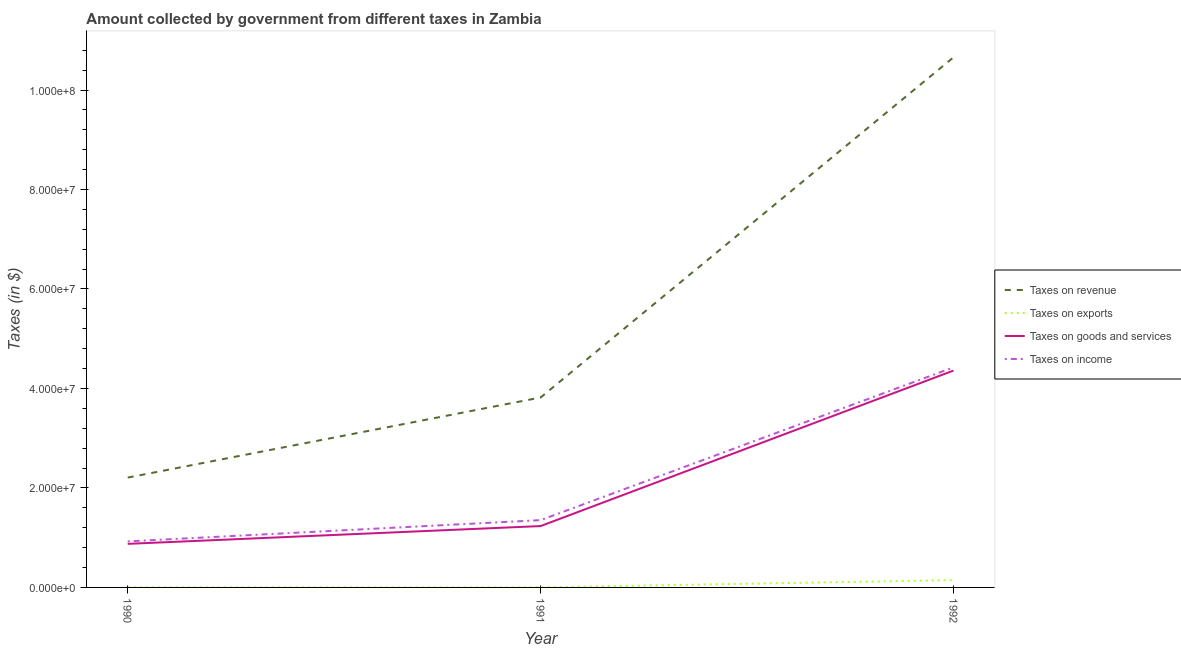How many different coloured lines are there?
Keep it short and to the point. 4. What is the amount collected as tax on revenue in 1992?
Provide a short and direct response. 1.07e+08. Across all years, what is the maximum amount collected as tax on revenue?
Your answer should be very brief. 1.07e+08. Across all years, what is the minimum amount collected as tax on revenue?
Your response must be concise. 2.21e+07. In which year was the amount collected as tax on revenue maximum?
Offer a very short reply. 1992. What is the total amount collected as tax on income in the graph?
Ensure brevity in your answer.  6.70e+07. What is the difference between the amount collected as tax on exports in 1990 and that in 1992?
Provide a succinct answer. -1.44e+06. What is the difference between the amount collected as tax on exports in 1991 and the amount collected as tax on income in 1990?
Offer a terse response. -9.24e+06. What is the average amount collected as tax on goods per year?
Offer a very short reply. 2.16e+07. In the year 1992, what is the difference between the amount collected as tax on goods and amount collected as tax on revenue?
Offer a very short reply. -6.30e+07. What is the ratio of the amount collected as tax on exports in 1991 to that in 1992?
Ensure brevity in your answer.  0.01. Is the amount collected as tax on revenue in 1990 less than that in 1992?
Provide a short and direct response. Yes. Is the difference between the amount collected as tax on exports in 1990 and 1991 greater than the difference between the amount collected as tax on revenue in 1990 and 1991?
Provide a succinct answer. Yes. What is the difference between the highest and the second highest amount collected as tax on revenue?
Provide a short and direct response. 6.84e+07. What is the difference between the highest and the lowest amount collected as tax on exports?
Ensure brevity in your answer.  1.46e+06. In how many years, is the amount collected as tax on income greater than the average amount collected as tax on income taken over all years?
Make the answer very short. 1. Is it the case that in every year, the sum of the amount collected as tax on revenue and amount collected as tax on income is greater than the sum of amount collected as tax on goods and amount collected as tax on exports?
Provide a short and direct response. No. Does the amount collected as tax on goods monotonically increase over the years?
Make the answer very short. Yes. Is the amount collected as tax on revenue strictly less than the amount collected as tax on exports over the years?
Give a very brief answer. No. How many lines are there?
Offer a very short reply. 4. How many years are there in the graph?
Make the answer very short. 3. Does the graph contain any zero values?
Keep it short and to the point. No. Where does the legend appear in the graph?
Your answer should be compact. Center right. How many legend labels are there?
Your answer should be very brief. 4. What is the title of the graph?
Your response must be concise. Amount collected by government from different taxes in Zambia. What is the label or title of the X-axis?
Offer a terse response. Year. What is the label or title of the Y-axis?
Offer a terse response. Taxes (in $). What is the Taxes (in $) of Taxes on revenue in 1990?
Provide a short and direct response. 2.21e+07. What is the Taxes (in $) in Taxes on exports in 1990?
Ensure brevity in your answer.  3.40e+04. What is the Taxes (in $) in Taxes on goods and services in 1990?
Your answer should be very brief. 8.76e+06. What is the Taxes (in $) of Taxes on income in 1990?
Make the answer very short. 9.25e+06. What is the Taxes (in $) in Taxes on revenue in 1991?
Your answer should be compact. 3.82e+07. What is the Taxes (in $) of Taxes on exports in 1991?
Your answer should be very brief. 1.19e+04. What is the Taxes (in $) of Taxes on goods and services in 1991?
Provide a succinct answer. 1.23e+07. What is the Taxes (in $) in Taxes on income in 1991?
Provide a short and direct response. 1.35e+07. What is the Taxes (in $) in Taxes on revenue in 1992?
Offer a terse response. 1.07e+08. What is the Taxes (in $) of Taxes on exports in 1992?
Your response must be concise. 1.47e+06. What is the Taxes (in $) of Taxes on goods and services in 1992?
Keep it short and to the point. 4.36e+07. What is the Taxes (in $) in Taxes on income in 1992?
Provide a succinct answer. 4.42e+07. Across all years, what is the maximum Taxes (in $) in Taxes on revenue?
Provide a succinct answer. 1.07e+08. Across all years, what is the maximum Taxes (in $) in Taxes on exports?
Offer a very short reply. 1.47e+06. Across all years, what is the maximum Taxes (in $) of Taxes on goods and services?
Keep it short and to the point. 4.36e+07. Across all years, what is the maximum Taxes (in $) in Taxes on income?
Offer a very short reply. 4.42e+07. Across all years, what is the minimum Taxes (in $) of Taxes on revenue?
Keep it short and to the point. 2.21e+07. Across all years, what is the minimum Taxes (in $) in Taxes on exports?
Make the answer very short. 1.19e+04. Across all years, what is the minimum Taxes (in $) in Taxes on goods and services?
Make the answer very short. 8.76e+06. Across all years, what is the minimum Taxes (in $) in Taxes on income?
Ensure brevity in your answer.  9.25e+06. What is the total Taxes (in $) in Taxes on revenue in the graph?
Offer a very short reply. 1.67e+08. What is the total Taxes (in $) of Taxes on exports in the graph?
Ensure brevity in your answer.  1.52e+06. What is the total Taxes (in $) of Taxes on goods and services in the graph?
Ensure brevity in your answer.  6.47e+07. What is the total Taxes (in $) of Taxes on income in the graph?
Your answer should be compact. 6.70e+07. What is the difference between the Taxes (in $) of Taxes on revenue in 1990 and that in 1991?
Your response must be concise. -1.61e+07. What is the difference between the Taxes (in $) in Taxes on exports in 1990 and that in 1991?
Provide a succinct answer. 2.21e+04. What is the difference between the Taxes (in $) in Taxes on goods and services in 1990 and that in 1991?
Offer a terse response. -3.58e+06. What is the difference between the Taxes (in $) of Taxes on income in 1990 and that in 1991?
Give a very brief answer. -4.27e+06. What is the difference between the Taxes (in $) in Taxes on revenue in 1990 and that in 1992?
Make the answer very short. -8.45e+07. What is the difference between the Taxes (in $) in Taxes on exports in 1990 and that in 1992?
Offer a terse response. -1.44e+06. What is the difference between the Taxes (in $) in Taxes on goods and services in 1990 and that in 1992?
Your response must be concise. -3.48e+07. What is the difference between the Taxes (in $) of Taxes on income in 1990 and that in 1992?
Provide a short and direct response. -3.50e+07. What is the difference between the Taxes (in $) of Taxes on revenue in 1991 and that in 1992?
Your answer should be compact. -6.84e+07. What is the difference between the Taxes (in $) in Taxes on exports in 1991 and that in 1992?
Provide a short and direct response. -1.46e+06. What is the difference between the Taxes (in $) in Taxes on goods and services in 1991 and that in 1992?
Give a very brief answer. -3.13e+07. What is the difference between the Taxes (in $) of Taxes on income in 1991 and that in 1992?
Your answer should be compact. -3.07e+07. What is the difference between the Taxes (in $) of Taxes on revenue in 1990 and the Taxes (in $) of Taxes on exports in 1991?
Provide a succinct answer. 2.21e+07. What is the difference between the Taxes (in $) in Taxes on revenue in 1990 and the Taxes (in $) in Taxes on goods and services in 1991?
Your response must be concise. 9.74e+06. What is the difference between the Taxes (in $) of Taxes on revenue in 1990 and the Taxes (in $) of Taxes on income in 1991?
Your answer should be very brief. 8.55e+06. What is the difference between the Taxes (in $) of Taxes on exports in 1990 and the Taxes (in $) of Taxes on goods and services in 1991?
Ensure brevity in your answer.  -1.23e+07. What is the difference between the Taxes (in $) in Taxes on exports in 1990 and the Taxes (in $) in Taxes on income in 1991?
Your response must be concise. -1.35e+07. What is the difference between the Taxes (in $) in Taxes on goods and services in 1990 and the Taxes (in $) in Taxes on income in 1991?
Provide a short and direct response. -4.77e+06. What is the difference between the Taxes (in $) in Taxes on revenue in 1990 and the Taxes (in $) in Taxes on exports in 1992?
Provide a succinct answer. 2.06e+07. What is the difference between the Taxes (in $) of Taxes on revenue in 1990 and the Taxes (in $) of Taxes on goods and services in 1992?
Provide a short and direct response. -2.15e+07. What is the difference between the Taxes (in $) of Taxes on revenue in 1990 and the Taxes (in $) of Taxes on income in 1992?
Provide a short and direct response. -2.22e+07. What is the difference between the Taxes (in $) in Taxes on exports in 1990 and the Taxes (in $) in Taxes on goods and services in 1992?
Give a very brief answer. -4.36e+07. What is the difference between the Taxes (in $) of Taxes on exports in 1990 and the Taxes (in $) of Taxes on income in 1992?
Ensure brevity in your answer.  -4.42e+07. What is the difference between the Taxes (in $) of Taxes on goods and services in 1990 and the Taxes (in $) of Taxes on income in 1992?
Provide a short and direct response. -3.55e+07. What is the difference between the Taxes (in $) in Taxes on revenue in 1991 and the Taxes (in $) in Taxes on exports in 1992?
Provide a succinct answer. 3.67e+07. What is the difference between the Taxes (in $) in Taxes on revenue in 1991 and the Taxes (in $) in Taxes on goods and services in 1992?
Ensure brevity in your answer.  -5.41e+06. What is the difference between the Taxes (in $) in Taxes on revenue in 1991 and the Taxes (in $) in Taxes on income in 1992?
Offer a very short reply. -6.06e+06. What is the difference between the Taxes (in $) in Taxes on exports in 1991 and the Taxes (in $) in Taxes on goods and services in 1992?
Make the answer very short. -4.36e+07. What is the difference between the Taxes (in $) of Taxes on exports in 1991 and the Taxes (in $) of Taxes on income in 1992?
Give a very brief answer. -4.42e+07. What is the difference between the Taxes (in $) of Taxes on goods and services in 1991 and the Taxes (in $) of Taxes on income in 1992?
Provide a succinct answer. -3.19e+07. What is the average Taxes (in $) in Taxes on revenue per year?
Keep it short and to the point. 5.56e+07. What is the average Taxes (in $) of Taxes on exports per year?
Keep it short and to the point. 5.05e+05. What is the average Taxes (in $) in Taxes on goods and services per year?
Make the answer very short. 2.16e+07. What is the average Taxes (in $) in Taxes on income per year?
Offer a very short reply. 2.23e+07. In the year 1990, what is the difference between the Taxes (in $) of Taxes on revenue and Taxes (in $) of Taxes on exports?
Your response must be concise. 2.20e+07. In the year 1990, what is the difference between the Taxes (in $) of Taxes on revenue and Taxes (in $) of Taxes on goods and services?
Your answer should be very brief. 1.33e+07. In the year 1990, what is the difference between the Taxes (in $) in Taxes on revenue and Taxes (in $) in Taxes on income?
Ensure brevity in your answer.  1.28e+07. In the year 1990, what is the difference between the Taxes (in $) in Taxes on exports and Taxes (in $) in Taxes on goods and services?
Offer a very short reply. -8.72e+06. In the year 1990, what is the difference between the Taxes (in $) in Taxes on exports and Taxes (in $) in Taxes on income?
Offer a terse response. -9.22e+06. In the year 1990, what is the difference between the Taxes (in $) of Taxes on goods and services and Taxes (in $) of Taxes on income?
Keep it short and to the point. -4.96e+05. In the year 1991, what is the difference between the Taxes (in $) of Taxes on revenue and Taxes (in $) of Taxes on exports?
Provide a succinct answer. 3.82e+07. In the year 1991, what is the difference between the Taxes (in $) in Taxes on revenue and Taxes (in $) in Taxes on goods and services?
Provide a short and direct response. 2.58e+07. In the year 1991, what is the difference between the Taxes (in $) in Taxes on revenue and Taxes (in $) in Taxes on income?
Your response must be concise. 2.47e+07. In the year 1991, what is the difference between the Taxes (in $) of Taxes on exports and Taxes (in $) of Taxes on goods and services?
Your answer should be very brief. -1.23e+07. In the year 1991, what is the difference between the Taxes (in $) in Taxes on exports and Taxes (in $) in Taxes on income?
Make the answer very short. -1.35e+07. In the year 1991, what is the difference between the Taxes (in $) in Taxes on goods and services and Taxes (in $) in Taxes on income?
Keep it short and to the point. -1.19e+06. In the year 1992, what is the difference between the Taxes (in $) in Taxes on revenue and Taxes (in $) in Taxes on exports?
Provide a short and direct response. 1.05e+08. In the year 1992, what is the difference between the Taxes (in $) of Taxes on revenue and Taxes (in $) of Taxes on goods and services?
Keep it short and to the point. 6.30e+07. In the year 1992, what is the difference between the Taxes (in $) in Taxes on revenue and Taxes (in $) in Taxes on income?
Make the answer very short. 6.23e+07. In the year 1992, what is the difference between the Taxes (in $) in Taxes on exports and Taxes (in $) in Taxes on goods and services?
Provide a short and direct response. -4.21e+07. In the year 1992, what is the difference between the Taxes (in $) of Taxes on exports and Taxes (in $) of Taxes on income?
Offer a terse response. -4.28e+07. In the year 1992, what is the difference between the Taxes (in $) in Taxes on goods and services and Taxes (in $) in Taxes on income?
Offer a terse response. -6.47e+05. What is the ratio of the Taxes (in $) of Taxes on revenue in 1990 to that in 1991?
Offer a terse response. 0.58. What is the ratio of the Taxes (in $) in Taxes on exports in 1990 to that in 1991?
Provide a succinct answer. 2.86. What is the ratio of the Taxes (in $) of Taxes on goods and services in 1990 to that in 1991?
Provide a succinct answer. 0.71. What is the ratio of the Taxes (in $) in Taxes on income in 1990 to that in 1991?
Offer a terse response. 0.68. What is the ratio of the Taxes (in $) in Taxes on revenue in 1990 to that in 1992?
Offer a very short reply. 0.21. What is the ratio of the Taxes (in $) in Taxes on exports in 1990 to that in 1992?
Your answer should be compact. 0.02. What is the ratio of the Taxes (in $) of Taxes on goods and services in 1990 to that in 1992?
Your response must be concise. 0.2. What is the ratio of the Taxes (in $) of Taxes on income in 1990 to that in 1992?
Ensure brevity in your answer.  0.21. What is the ratio of the Taxes (in $) of Taxes on revenue in 1991 to that in 1992?
Ensure brevity in your answer.  0.36. What is the ratio of the Taxes (in $) of Taxes on exports in 1991 to that in 1992?
Give a very brief answer. 0.01. What is the ratio of the Taxes (in $) in Taxes on goods and services in 1991 to that in 1992?
Ensure brevity in your answer.  0.28. What is the ratio of the Taxes (in $) in Taxes on income in 1991 to that in 1992?
Your answer should be very brief. 0.31. What is the difference between the highest and the second highest Taxes (in $) in Taxes on revenue?
Keep it short and to the point. 6.84e+07. What is the difference between the highest and the second highest Taxes (in $) in Taxes on exports?
Provide a succinct answer. 1.44e+06. What is the difference between the highest and the second highest Taxes (in $) of Taxes on goods and services?
Your response must be concise. 3.13e+07. What is the difference between the highest and the second highest Taxes (in $) in Taxes on income?
Keep it short and to the point. 3.07e+07. What is the difference between the highest and the lowest Taxes (in $) in Taxes on revenue?
Offer a terse response. 8.45e+07. What is the difference between the highest and the lowest Taxes (in $) in Taxes on exports?
Provide a succinct answer. 1.46e+06. What is the difference between the highest and the lowest Taxes (in $) in Taxes on goods and services?
Offer a very short reply. 3.48e+07. What is the difference between the highest and the lowest Taxes (in $) of Taxes on income?
Make the answer very short. 3.50e+07. 